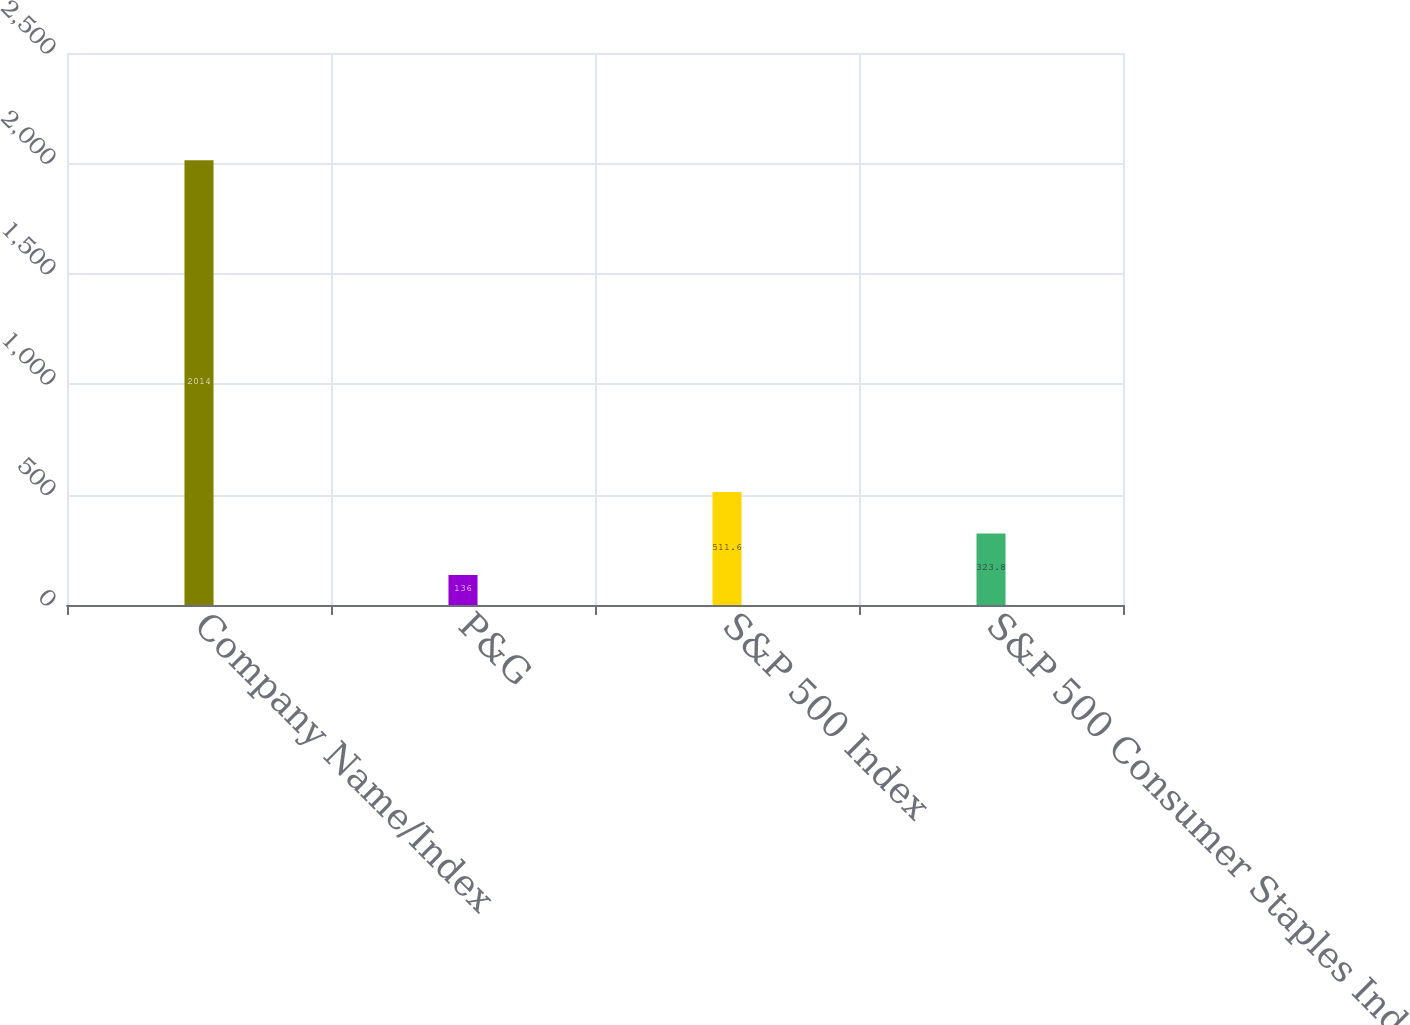Convert chart to OTSL. <chart><loc_0><loc_0><loc_500><loc_500><bar_chart><fcel>Company Name/Index<fcel>P&G<fcel>S&P 500 Index<fcel>S&P 500 Consumer Staples Index<nl><fcel>2014<fcel>136<fcel>511.6<fcel>323.8<nl></chart> 